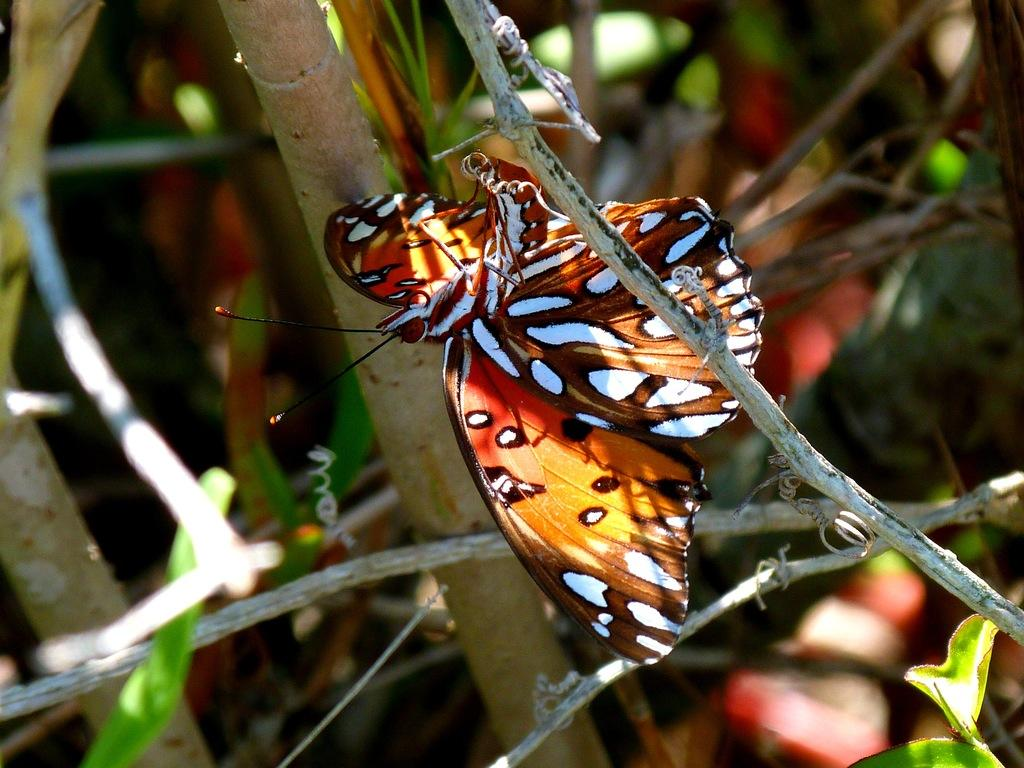Where was the picture taken? The picture was taken outside. What can be seen in the image besides the outdoor setting? There is an orange-colored moth in the image. What is the moth doing in the image? The moth is sitting on a tree branch. What can be observed about the tree in the image? The tree has visible stems in the background. What else is present in the background of the image? There are other unspecified objects in the background. What type of comb is being used to create the art in the image? There is no comb or art present in the image; it features an orange-colored moth sitting on a tree branch. What time of day is depicted in the image? The time of day is not specified in the image, as it only shows an orange-colored moth sitting on a tree branch. 